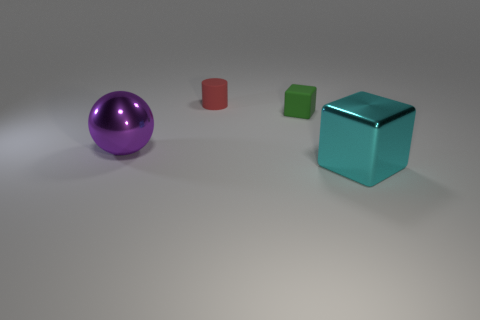What characteristics distinguish the purple spherical object from the other objects in this image? The purple spherical object differs from the others primarily in its color and shape. While the other objects are more angular with distinct edges, the purple object is round, presenting a smooth curvature. Additionally, its reflective surface suggests it may be made of a different material than the matte surfaces of the other objects. It also stands out due to its positioning, as it is separated from the group, which could suggest importance or individuality within the context of the image. 